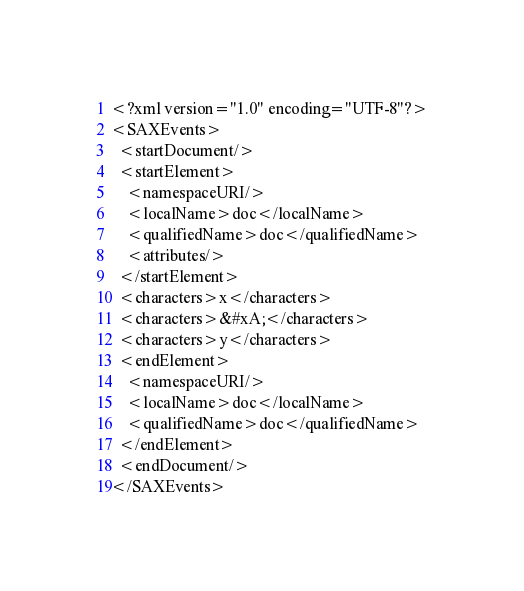<code> <loc_0><loc_0><loc_500><loc_500><_XML_><?xml version="1.0" encoding="UTF-8"?>
<SAXEvents>
  <startDocument/>
  <startElement>
    <namespaceURI/>
    <localName>doc</localName>
    <qualifiedName>doc</qualifiedName>
    <attributes/>
  </startElement>
  <characters>x</characters>
  <characters>&#xA;</characters>
  <characters>y</characters>
  <endElement>
    <namespaceURI/>
    <localName>doc</localName>
    <qualifiedName>doc</qualifiedName>
  </endElement>
  <endDocument/>
</SAXEvents>
</code> 